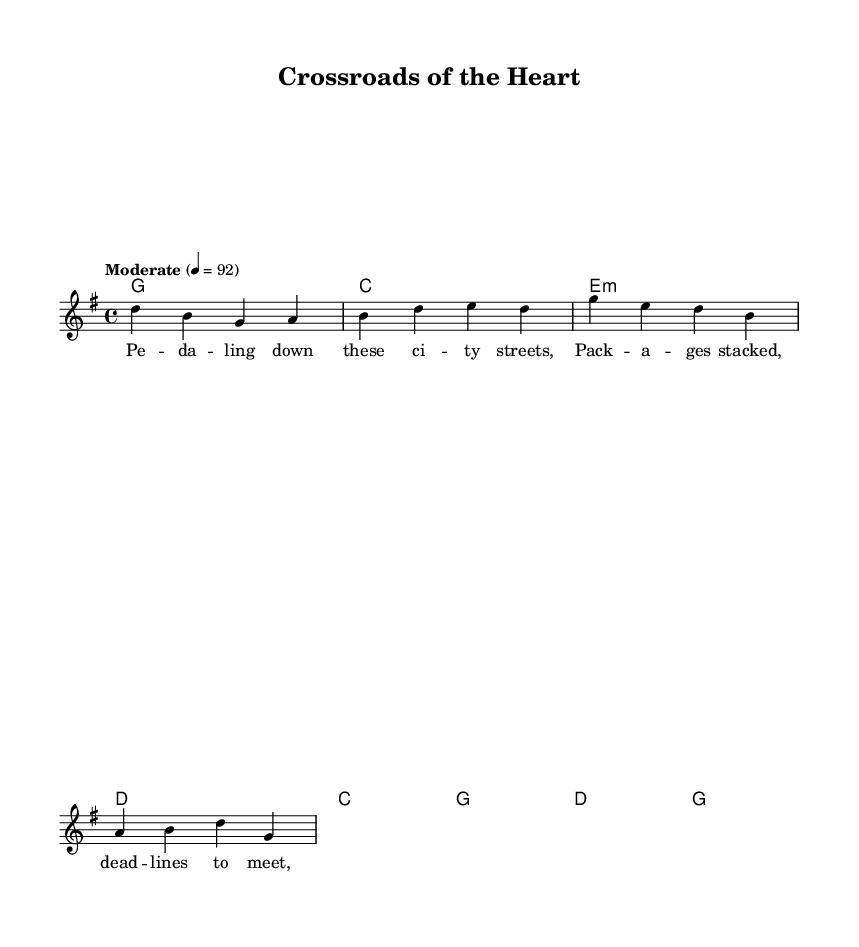What is the title of this music? The title is indicated in the header section of the sheet music. It reads "Crossroads of the Heart".
Answer: Crossroads of the Heart What is the key signature of this music? The key signature is shown at the beginning of the global section and indicates G major, which has one sharp (F#).
Answer: G major What is the time signature of this music? The time signature is listed in the global section as 4/4, which means there are four beats per measure and a quarter note gets one beat.
Answer: 4/4 What is the tempo marking? The tempo marking in the global section indicates "Moderate" at a speed of 92 beats per minute.
Answer: Moderate How many measures are in the verse? To find the number of measures in the verse, we count the bars of melody under the verseWords. There are four measures.
Answer: Four What are the lyrics of the chorus? The lyrics of the chorus can be found in the chorusWords section, which are presented right after the verseWords. The words are "Crossroads of the heart, Where strangers' paths can start."
Answer: Crossroads of the heart, Where strangers' paths can start Which element signifies the song's genre as Country Rock? The song expresses heartfelt themes and storytelling elements, as seen in the context of the lyrics and structure that includes common themes like chance encounters. This style typically focuses on narratives of personal experiences.
Answer: Heartfelt storytelling 